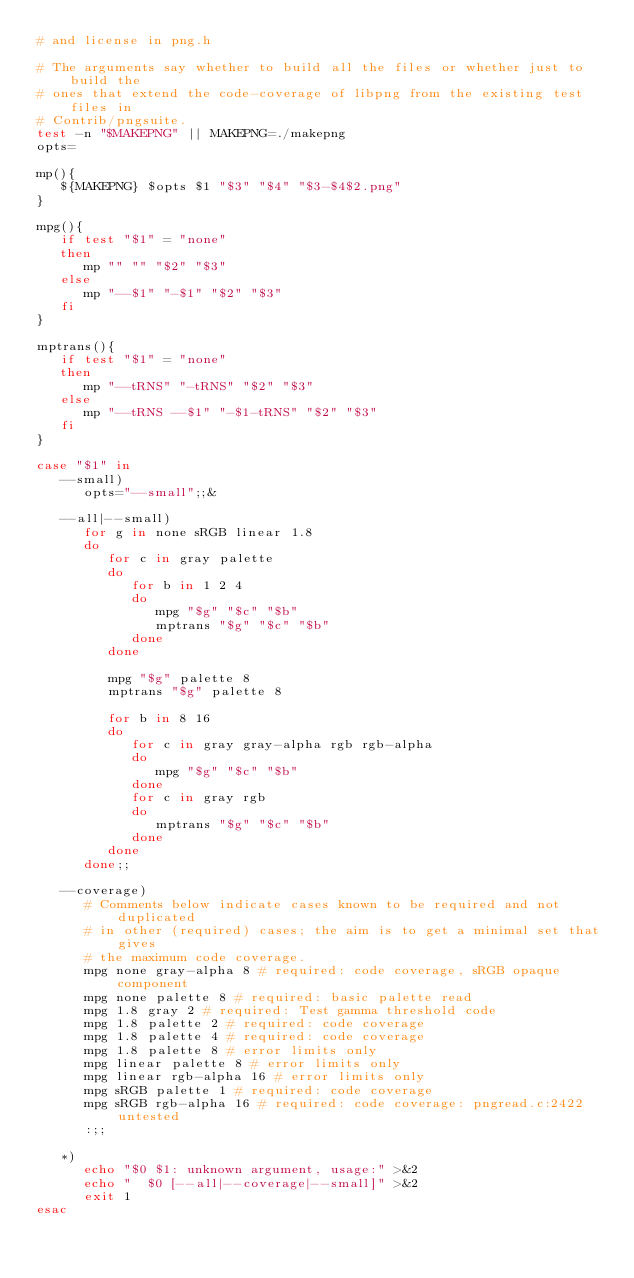Convert code to text. <code><loc_0><loc_0><loc_500><loc_500><_Bash_># and license in png.h

# The arguments say whether to build all the files or whether just to build the
# ones that extend the code-coverage of libpng from the existing test files in
# Contrib/pngsuite.
test -n "$MAKEPNG" || MAKEPNG=./makepng
opts=

mp(){
   ${MAKEPNG} $opts $1 "$3" "$4" "$3-$4$2.png"
}

mpg(){
   if test "$1" = "none"
   then
      mp "" "" "$2" "$3"
   else
      mp "--$1" "-$1" "$2" "$3"
   fi
}

mptrans(){
   if test "$1" = "none"
   then
      mp "--tRNS" "-tRNS" "$2" "$3"
   else
      mp "--tRNS --$1" "-$1-tRNS" "$2" "$3"
   fi
}

case "$1" in
   --small)
      opts="--small";;&

   --all|--small)
      for g in none sRGB linear 1.8
      do
         for c in gray palette
         do
            for b in 1 2 4
            do
               mpg "$g" "$c" "$b"
               mptrans "$g" "$c" "$b"
            done
         done

         mpg "$g" palette 8
         mptrans "$g" palette 8

         for b in 8 16
         do
            for c in gray gray-alpha rgb rgb-alpha
            do
               mpg "$g" "$c" "$b"
            done
            for c in gray rgb
            do
               mptrans "$g" "$c" "$b"
            done
         done
      done;;

   --coverage)
      # Comments below indicate cases known to be required and not duplicated
      # in other (required) cases; the aim is to get a minimal set that gives
      # the maximum code coverage.
      mpg none gray-alpha 8 # required: code coverage, sRGB opaque component
      mpg none palette 8 # required: basic palette read
      mpg 1.8 gray 2 # required: Test gamma threshold code
      mpg 1.8 palette 2 # required: code coverage
      mpg 1.8 palette 4 # required: code coverage
      mpg 1.8 palette 8 # error limits only
      mpg linear palette 8 # error limits only
      mpg linear rgb-alpha 16 # error limits only
      mpg sRGB palette 1 # required: code coverage
      mpg sRGB rgb-alpha 16 # required: code coverage: pngread.c:2422 untested
      :;;

   *)
      echo "$0 $1: unknown argument, usage:" >&2
      echo "  $0 [--all|--coverage|--small]" >&2
      exit 1
esac
</code> 